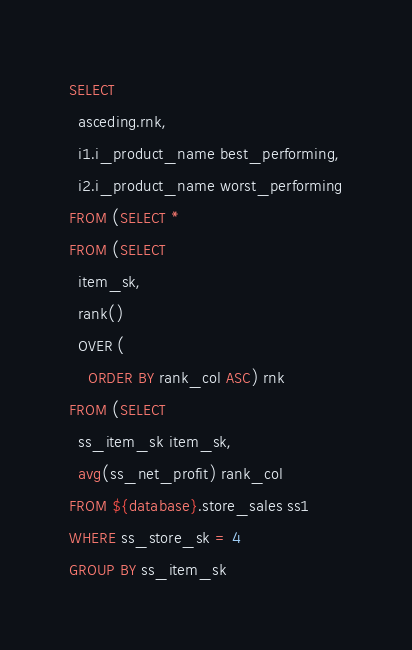Convert code to text. <code><loc_0><loc_0><loc_500><loc_500><_SQL_>SELECT
  asceding.rnk,
  i1.i_product_name best_performing,
  i2.i_product_name worst_performing
FROM (SELECT *
FROM (SELECT
  item_sk,
  rank()
  OVER (
    ORDER BY rank_col ASC) rnk
FROM (SELECT
  ss_item_sk item_sk,
  avg(ss_net_profit) rank_col
FROM ${database}.store_sales ss1
WHERE ss_store_sk = 4
GROUP BY ss_item_sk</code> 